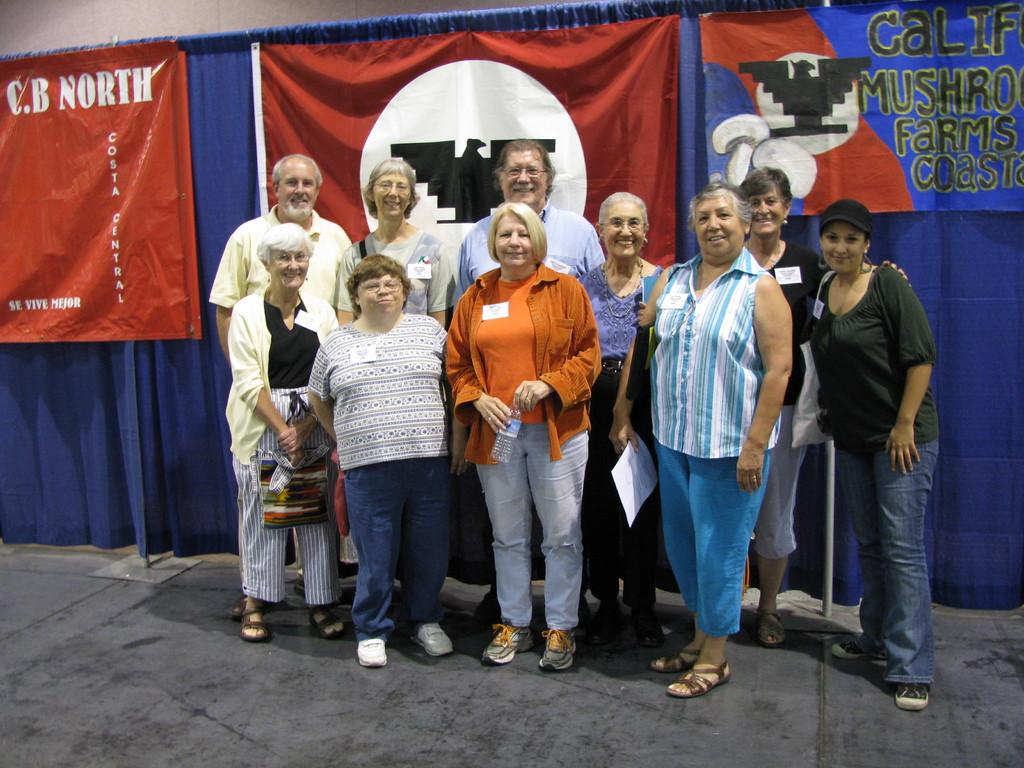What is happening in the image involving the group of people? The people in the image are standing and smiling. What are some of the people holding in the image? Some people are holding a paper and a water bottle. What can be seen in the background of the image? There are banners visible in the background. What type of curtain is present in the image? There is a blue curtain in the image. How many oranges are being used to create harmony in the image? There are no oranges present in the image, and harmony is not a tangible object that can be created with oranges. 